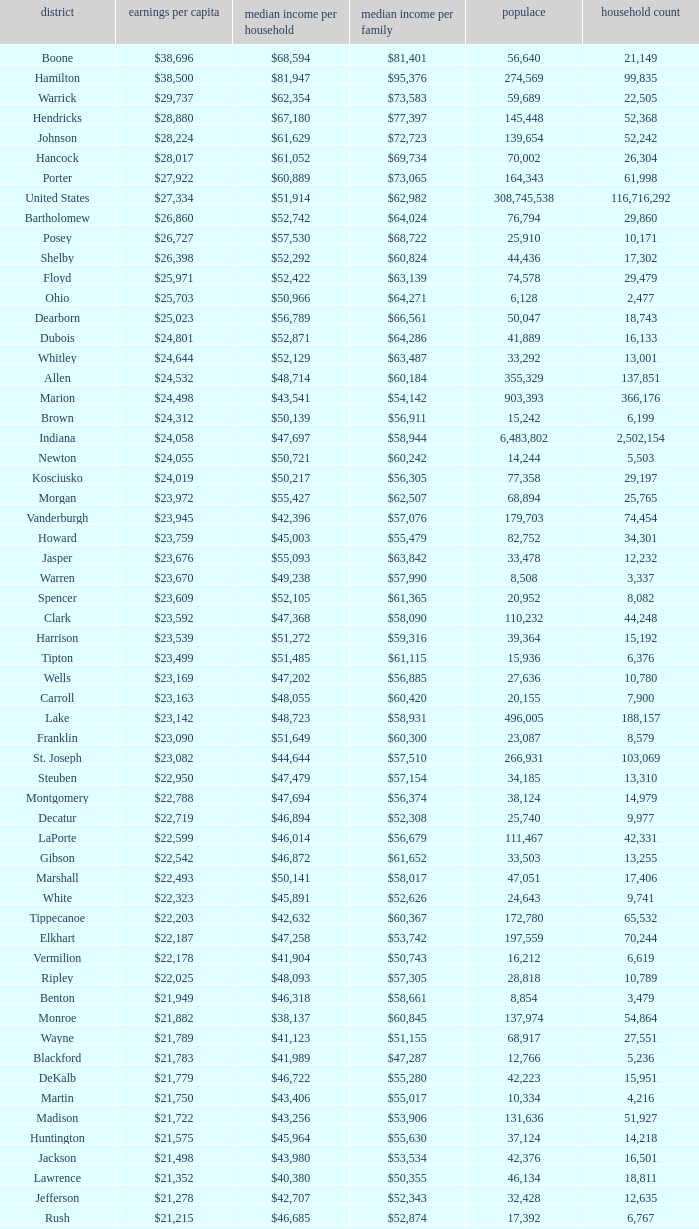What is the Median family income when the Median household income is $38,137? $60,845. 